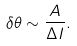Convert formula to latex. <formula><loc_0><loc_0><loc_500><loc_500>\delta \theta \sim \frac { A } { \Delta I } .</formula> 